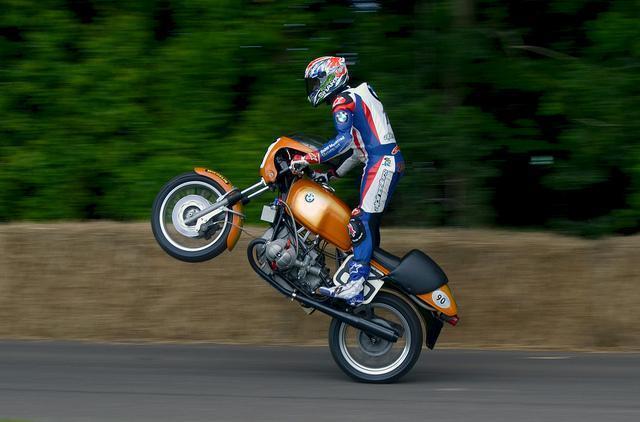How many tires are on the ground?
Give a very brief answer. 1. How many people are visible?
Give a very brief answer. 1. How many brown cats are there?
Give a very brief answer. 0. 